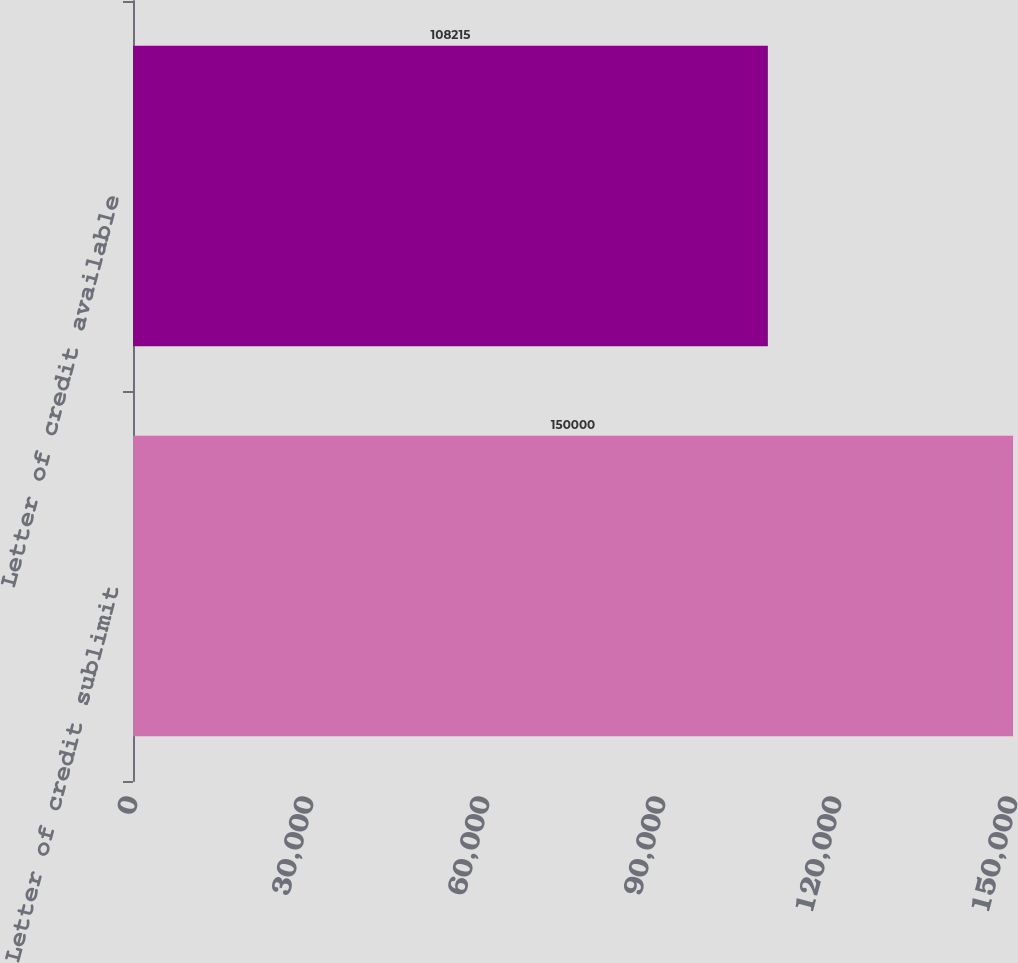Convert chart to OTSL. <chart><loc_0><loc_0><loc_500><loc_500><bar_chart><fcel>Letter of credit sublimit<fcel>Letter of credit available<nl><fcel>150000<fcel>108215<nl></chart> 